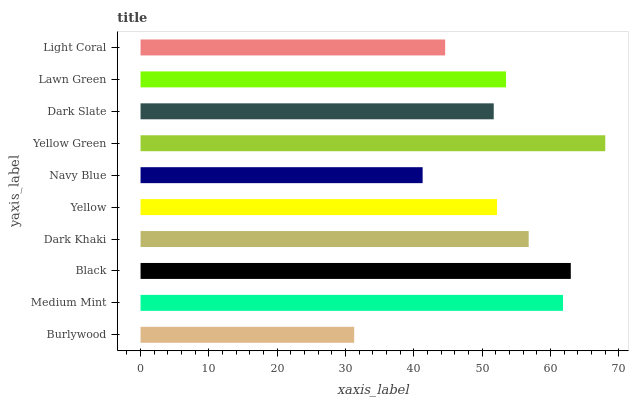Is Burlywood the minimum?
Answer yes or no. Yes. Is Yellow Green the maximum?
Answer yes or no. Yes. Is Medium Mint the minimum?
Answer yes or no. No. Is Medium Mint the maximum?
Answer yes or no. No. Is Medium Mint greater than Burlywood?
Answer yes or no. Yes. Is Burlywood less than Medium Mint?
Answer yes or no. Yes. Is Burlywood greater than Medium Mint?
Answer yes or no. No. Is Medium Mint less than Burlywood?
Answer yes or no. No. Is Lawn Green the high median?
Answer yes or no. Yes. Is Yellow the low median?
Answer yes or no. Yes. Is Light Coral the high median?
Answer yes or no. No. Is Dark Khaki the low median?
Answer yes or no. No. 